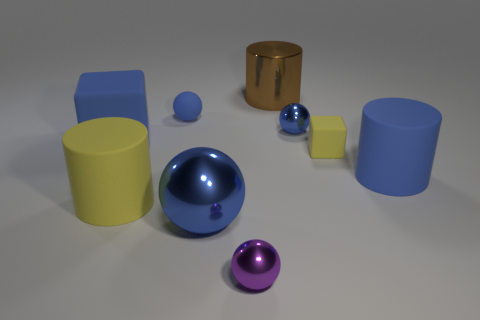Subtract all blue spheres. How many were subtracted if there are1blue spheres left? 2 Subtract all gray cylinders. How many blue balls are left? 3 Subtract 1 balls. How many balls are left? 3 Add 1 big blue rubber objects. How many objects exist? 10 Subtract all cylinders. How many objects are left? 6 Add 2 large metal balls. How many large metal balls exist? 3 Subtract 0 gray cylinders. How many objects are left? 9 Subtract all large yellow matte cylinders. Subtract all brown metallic objects. How many objects are left? 7 Add 5 big rubber cylinders. How many big rubber cylinders are left? 7 